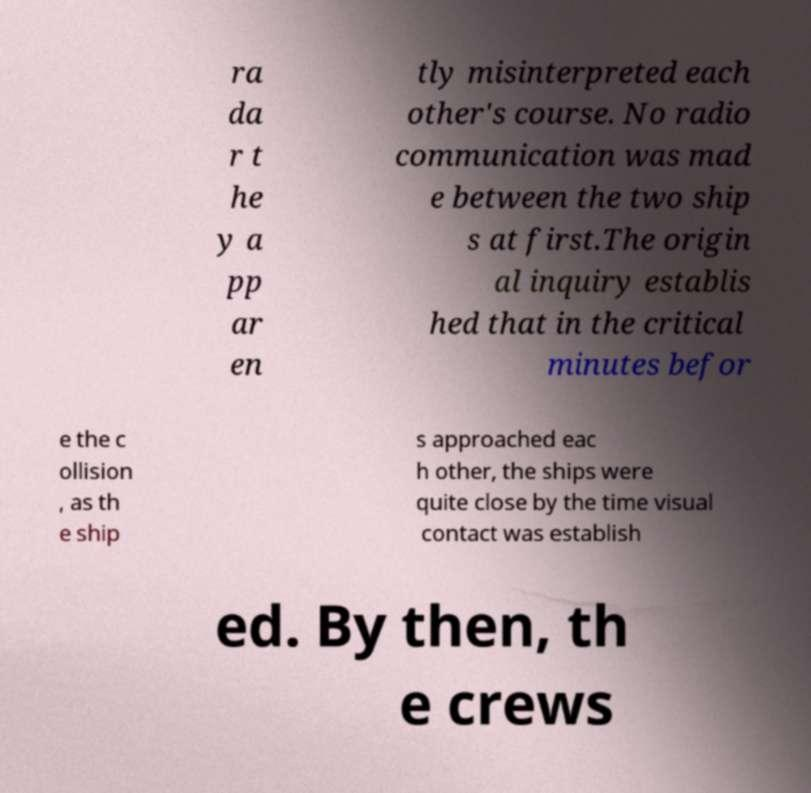Please identify and transcribe the text found in this image. ra da r t he y a pp ar en tly misinterpreted each other's course. No radio communication was mad e between the two ship s at first.The origin al inquiry establis hed that in the critical minutes befor e the c ollision , as th e ship s approached eac h other, the ships were quite close by the time visual contact was establish ed. By then, th e crews 